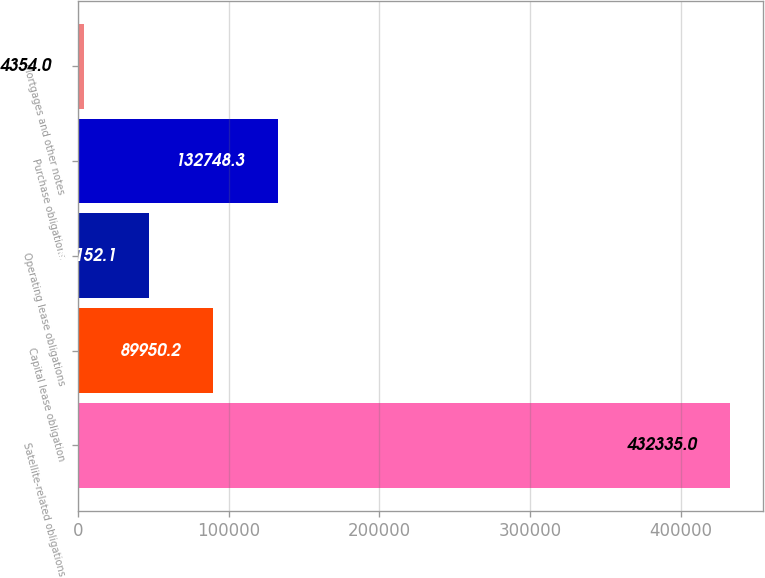Convert chart to OTSL. <chart><loc_0><loc_0><loc_500><loc_500><bar_chart><fcel>Satellite-related obligations<fcel>Capital lease obligation<fcel>Operating lease obligations<fcel>Purchase obligations<fcel>Mortgages and other notes<nl><fcel>432335<fcel>89950.2<fcel>47152.1<fcel>132748<fcel>4354<nl></chart> 